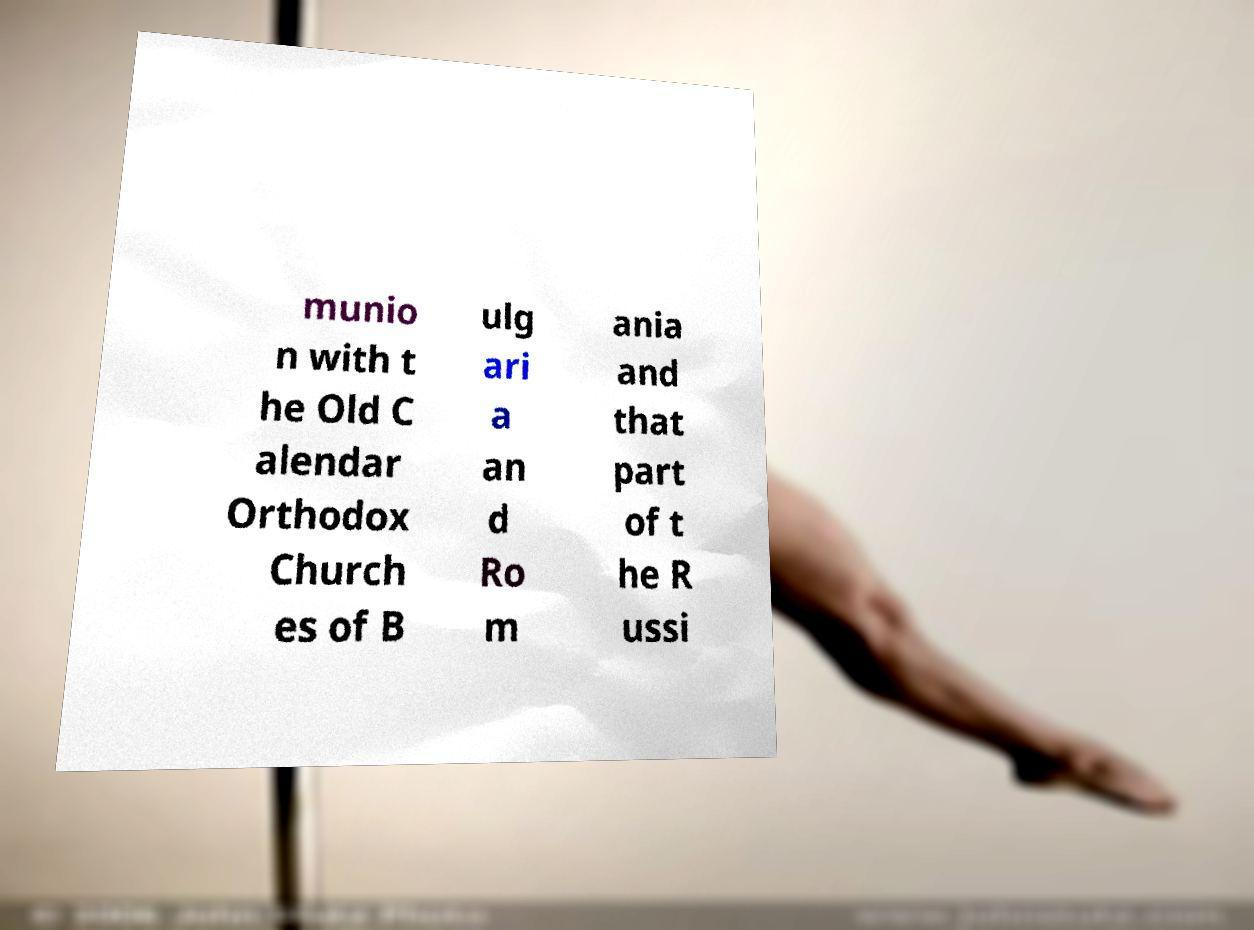I need the written content from this picture converted into text. Can you do that? munio n with t he Old C alendar Orthodox Church es of B ulg ari a an d Ro m ania and that part of t he R ussi 